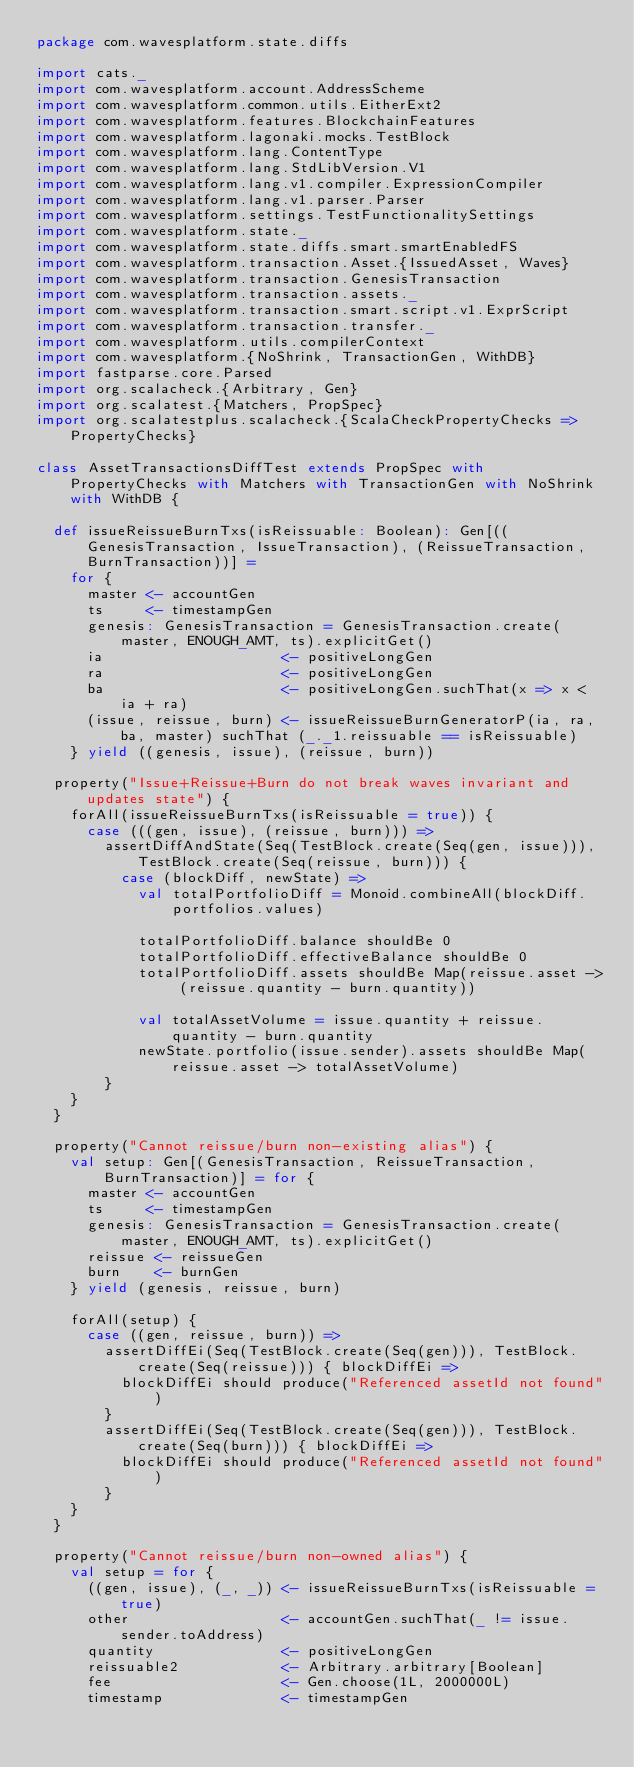Convert code to text. <code><loc_0><loc_0><loc_500><loc_500><_Scala_>package com.wavesplatform.state.diffs

import cats._
import com.wavesplatform.account.AddressScheme
import com.wavesplatform.common.utils.EitherExt2
import com.wavesplatform.features.BlockchainFeatures
import com.wavesplatform.lagonaki.mocks.TestBlock
import com.wavesplatform.lang.ContentType
import com.wavesplatform.lang.StdLibVersion.V1
import com.wavesplatform.lang.v1.compiler.ExpressionCompiler
import com.wavesplatform.lang.v1.parser.Parser
import com.wavesplatform.settings.TestFunctionalitySettings
import com.wavesplatform.state._
import com.wavesplatform.state.diffs.smart.smartEnabledFS
import com.wavesplatform.transaction.Asset.{IssuedAsset, Waves}
import com.wavesplatform.transaction.GenesisTransaction
import com.wavesplatform.transaction.assets._
import com.wavesplatform.transaction.smart.script.v1.ExprScript
import com.wavesplatform.transaction.transfer._
import com.wavesplatform.utils.compilerContext
import com.wavesplatform.{NoShrink, TransactionGen, WithDB}
import fastparse.core.Parsed
import org.scalacheck.{Arbitrary, Gen}
import org.scalatest.{Matchers, PropSpec}
import org.scalatestplus.scalacheck.{ScalaCheckPropertyChecks => PropertyChecks}

class AssetTransactionsDiffTest extends PropSpec with PropertyChecks with Matchers with TransactionGen with NoShrink with WithDB {

  def issueReissueBurnTxs(isReissuable: Boolean): Gen[((GenesisTransaction, IssueTransaction), (ReissueTransaction, BurnTransaction))] =
    for {
      master <- accountGen
      ts     <- timestampGen
      genesis: GenesisTransaction = GenesisTransaction.create(master, ENOUGH_AMT, ts).explicitGet()
      ia                     <- positiveLongGen
      ra                     <- positiveLongGen
      ba                     <- positiveLongGen.suchThat(x => x < ia + ra)
      (issue, reissue, burn) <- issueReissueBurnGeneratorP(ia, ra, ba, master) suchThat (_._1.reissuable == isReissuable)
    } yield ((genesis, issue), (reissue, burn))

  property("Issue+Reissue+Burn do not break waves invariant and updates state") {
    forAll(issueReissueBurnTxs(isReissuable = true)) {
      case (((gen, issue), (reissue, burn))) =>
        assertDiffAndState(Seq(TestBlock.create(Seq(gen, issue))), TestBlock.create(Seq(reissue, burn))) {
          case (blockDiff, newState) =>
            val totalPortfolioDiff = Monoid.combineAll(blockDiff.portfolios.values)

            totalPortfolioDiff.balance shouldBe 0
            totalPortfolioDiff.effectiveBalance shouldBe 0
            totalPortfolioDiff.assets shouldBe Map(reissue.asset -> (reissue.quantity - burn.quantity))

            val totalAssetVolume = issue.quantity + reissue.quantity - burn.quantity
            newState.portfolio(issue.sender).assets shouldBe Map(reissue.asset -> totalAssetVolume)
        }
    }
  }

  property("Cannot reissue/burn non-existing alias") {
    val setup: Gen[(GenesisTransaction, ReissueTransaction, BurnTransaction)] = for {
      master <- accountGen
      ts     <- timestampGen
      genesis: GenesisTransaction = GenesisTransaction.create(master, ENOUGH_AMT, ts).explicitGet()
      reissue <- reissueGen
      burn    <- burnGen
    } yield (genesis, reissue, burn)

    forAll(setup) {
      case ((gen, reissue, burn)) =>
        assertDiffEi(Seq(TestBlock.create(Seq(gen))), TestBlock.create(Seq(reissue))) { blockDiffEi =>
          blockDiffEi should produce("Referenced assetId not found")
        }
        assertDiffEi(Seq(TestBlock.create(Seq(gen))), TestBlock.create(Seq(burn))) { blockDiffEi =>
          blockDiffEi should produce("Referenced assetId not found")
        }
    }
  }

  property("Cannot reissue/burn non-owned alias") {
    val setup = for {
      ((gen, issue), (_, _)) <- issueReissueBurnTxs(isReissuable = true)
      other                  <- accountGen.suchThat(_ != issue.sender.toAddress)
      quantity               <- positiveLongGen
      reissuable2            <- Arbitrary.arbitrary[Boolean]
      fee                    <- Gen.choose(1L, 2000000L)
      timestamp              <- timestampGen</code> 